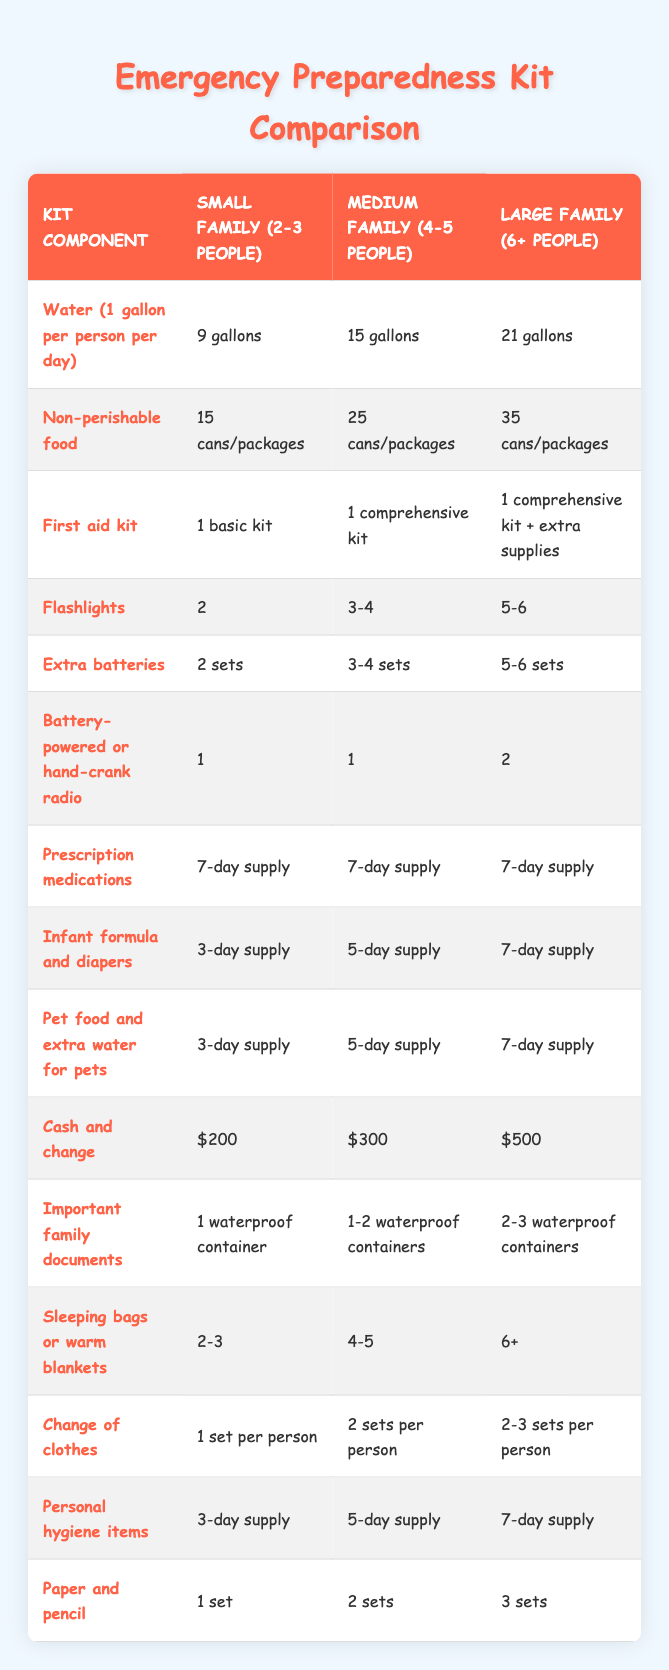What is the total amount of water needed for a medium family? According to the table, a medium family (4-5 people) needs 15 gallons of water. This value is directly retrieved from the relevant row.
Answer: 15 gallons How many cans/packages of non-perishable food does a large family require? The table shows that a large family (6+ people) needs 35 cans/packages of non-perishable food. This fact is found in the corresponding row of the table.
Answer: 35 cans/packages Does a small family need more or less than a medium family for sleeping bags? A small family needs 2-3 sleeping bags while a medium family requires 4-5 sleeping bags. Since 2-3 is less than 4-5, we can confirm that a small family needs less. This comparison is based on the values in the sleeping bags row.
Answer: Less What is the sum of cash and change required for a small and a large family? For a small family, the cash and change required is $200 and for a large family, it is $500. Adding these together gives $200 + $500 = $700. This is calculated by directly adding the respective values in the cash row.
Answer: $700 How many flashlights should a medium family prepare for an emergency? The table indicates that a medium family (4-5 people) should prepare 3-4 flashlights. This is a direct retrieval from the flashlights data row.
Answer: 3-4 flashlights Is it true that both small and medium families need the same supply of prescription medications? Yes, both the small family and the medium family require a 7-day supply of prescription medications. This fact is verified by looking at the prescription medications row in the table.
Answer: True What range of sets of extra batteries is needed for a large family compared to a small family? A small family requires 2 sets of extra batteries, while a large family requires 5-6 sets. The difference of minimum and maximum sets indicates a broader range for large families.
Answer: Greater range How many sets of personal hygiene items are needed for a medium family? According to the table, a medium family needs a 5-day supply of personal hygiene items. This information is directly found in the personal hygiene row.
Answer: 5-day supply What is the average number of sleeping bags needed per person in a large family? A large family requires 6+ sleeping bags, and if we average this as a minimum of 6 for estimation and there are at least 6 people, the average is 6/6 = 1. So, taking the minimum, it suggests they would ideally need at least 1 sleeping bag per person.
Answer: 1 sleeping bag per person 